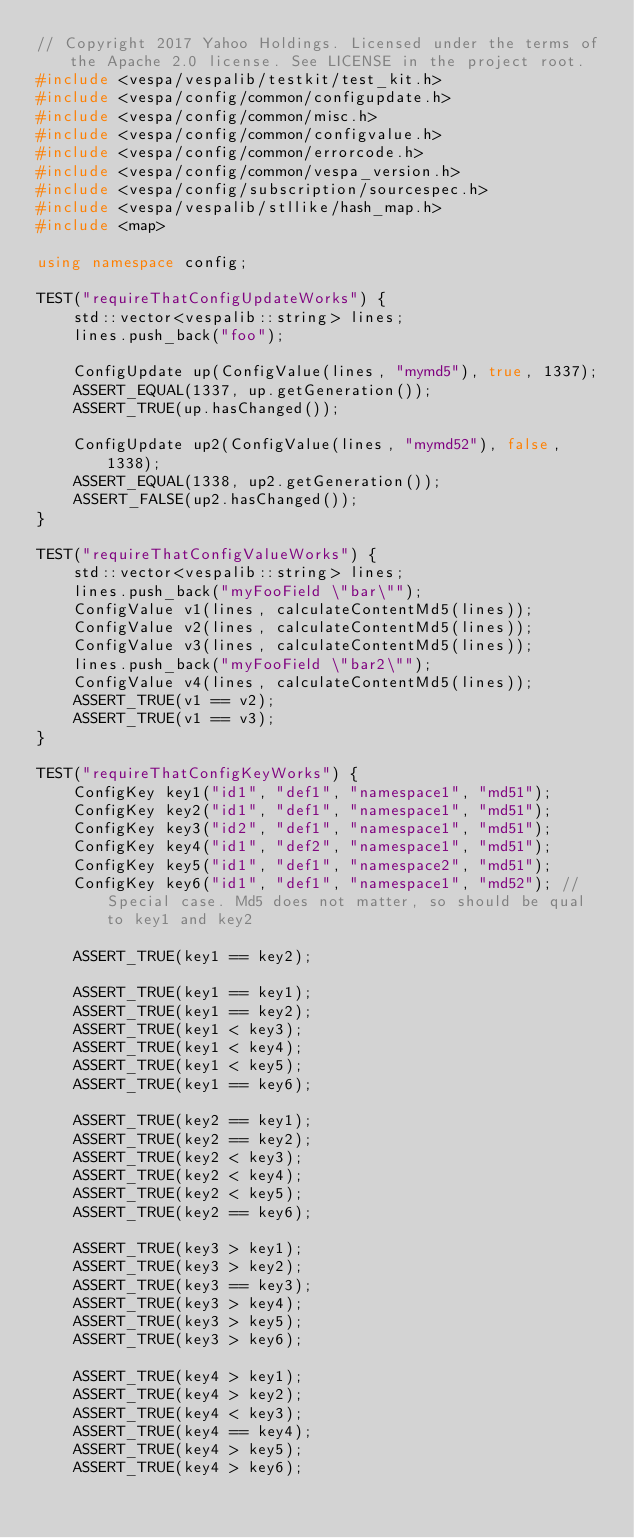Convert code to text. <code><loc_0><loc_0><loc_500><loc_500><_C++_>// Copyright 2017 Yahoo Holdings. Licensed under the terms of the Apache 2.0 license. See LICENSE in the project root.
#include <vespa/vespalib/testkit/test_kit.h>
#include <vespa/config/common/configupdate.h>
#include <vespa/config/common/misc.h>
#include <vespa/config/common/configvalue.h>
#include <vespa/config/common/errorcode.h>
#include <vespa/config/common/vespa_version.h>
#include <vespa/config/subscription/sourcespec.h>
#include <vespa/vespalib/stllike/hash_map.h>
#include <map>

using namespace config;

TEST("requireThatConfigUpdateWorks") {
    std::vector<vespalib::string> lines;
    lines.push_back("foo");

    ConfigUpdate up(ConfigValue(lines, "mymd5"), true, 1337);
    ASSERT_EQUAL(1337, up.getGeneration());
    ASSERT_TRUE(up.hasChanged());

    ConfigUpdate up2(ConfigValue(lines, "mymd52"), false, 1338);
    ASSERT_EQUAL(1338, up2.getGeneration());
    ASSERT_FALSE(up2.hasChanged());
}

TEST("requireThatConfigValueWorks") {
    std::vector<vespalib::string> lines;
    lines.push_back("myFooField \"bar\"");
    ConfigValue v1(lines, calculateContentMd5(lines));
    ConfigValue v2(lines, calculateContentMd5(lines));
    ConfigValue v3(lines, calculateContentMd5(lines));
    lines.push_back("myFooField \"bar2\"");
    ConfigValue v4(lines, calculateContentMd5(lines));
    ASSERT_TRUE(v1 == v2);
    ASSERT_TRUE(v1 == v3);
}

TEST("requireThatConfigKeyWorks") {
    ConfigKey key1("id1", "def1", "namespace1", "md51");
    ConfigKey key2("id1", "def1", "namespace1", "md51");
    ConfigKey key3("id2", "def1", "namespace1", "md51");
    ConfigKey key4("id1", "def2", "namespace1", "md51");
    ConfigKey key5("id1", "def1", "namespace2", "md51");
    ConfigKey key6("id1", "def1", "namespace1", "md52"); // Special case. Md5 does not matter, so should be qual to key1 and key2

    ASSERT_TRUE(key1 == key2);

    ASSERT_TRUE(key1 == key1);
    ASSERT_TRUE(key1 == key2);
    ASSERT_TRUE(key1 < key3);
    ASSERT_TRUE(key1 < key4);
    ASSERT_TRUE(key1 < key5);
    ASSERT_TRUE(key1 == key6);

    ASSERT_TRUE(key2 == key1);
    ASSERT_TRUE(key2 == key2);
    ASSERT_TRUE(key2 < key3);
    ASSERT_TRUE(key2 < key4);
    ASSERT_TRUE(key2 < key5);
    ASSERT_TRUE(key2 == key6);

    ASSERT_TRUE(key3 > key1);
    ASSERT_TRUE(key3 > key2);
    ASSERT_TRUE(key3 == key3);
    ASSERT_TRUE(key3 > key4);
    ASSERT_TRUE(key3 > key5);
    ASSERT_TRUE(key3 > key6);

    ASSERT_TRUE(key4 > key1);
    ASSERT_TRUE(key4 > key2);
    ASSERT_TRUE(key4 < key3);
    ASSERT_TRUE(key4 == key4);
    ASSERT_TRUE(key4 > key5);
    ASSERT_TRUE(key4 > key6);
</code> 